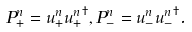Convert formula to latex. <formula><loc_0><loc_0><loc_500><loc_500>P ^ { n } _ { + } = { u } ^ { n } _ { + } { { u } ^ { n } _ { + } } ^ { \dagger } , P ^ { n } _ { - } = { u } ^ { n } _ { - } { { u } ^ { n } _ { - } } ^ { \dagger } .</formula> 